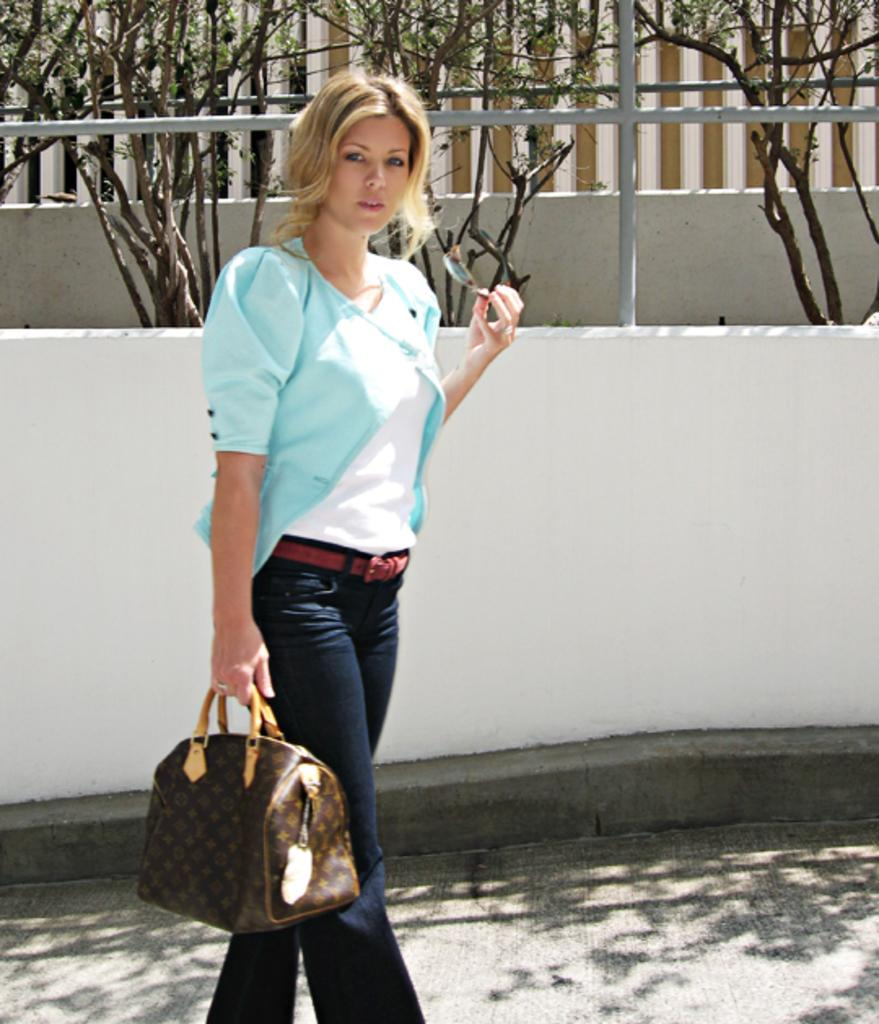What is the main subject of the image? There is a woman in the image. What is the woman doing in the image? The woman is standing in the image. What is the woman holding in her hands? The woman is holding a bag in one hand and glasses in the other hand. What can be seen in the background of the image? There is a fence, a building, and plants in the background of the image. What type of argument is the woman having with the dogs in the image? There are no dogs present in the image, and therefore no argument can be observed. 